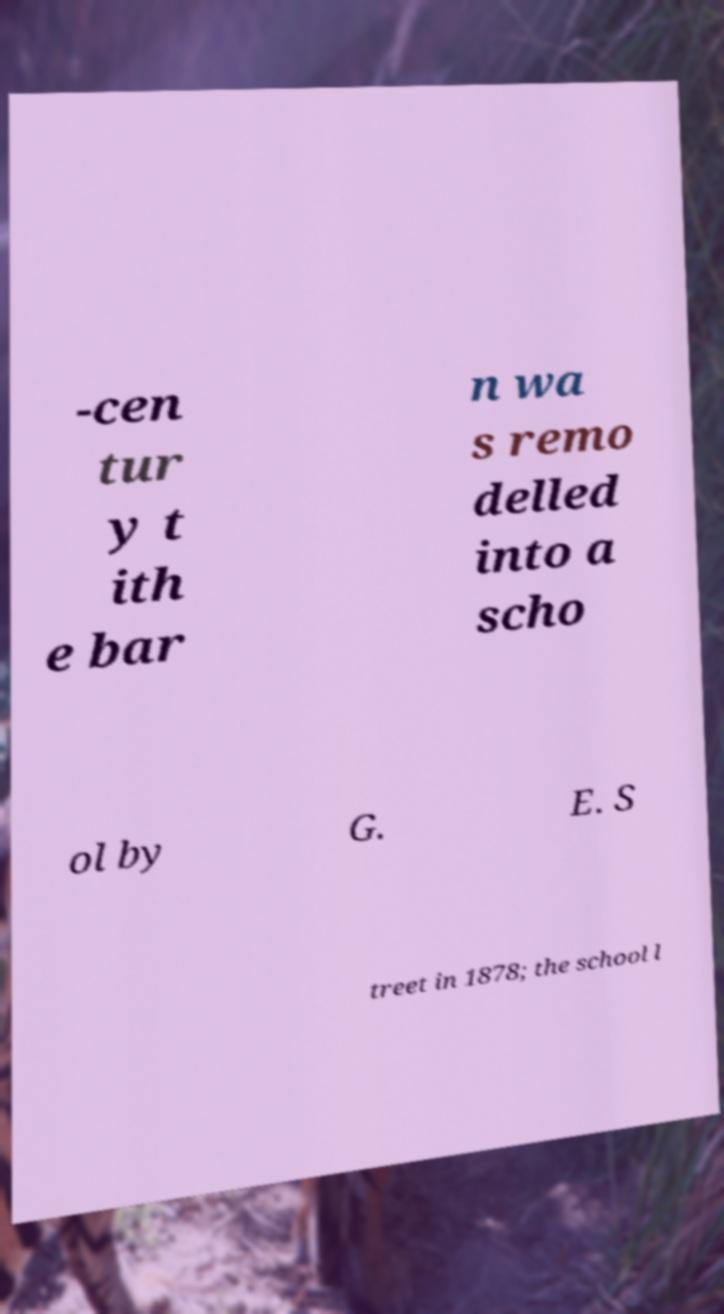Could you extract and type out the text from this image? -cen tur y t ith e bar n wa s remo delled into a scho ol by G. E. S treet in 1878; the school l 